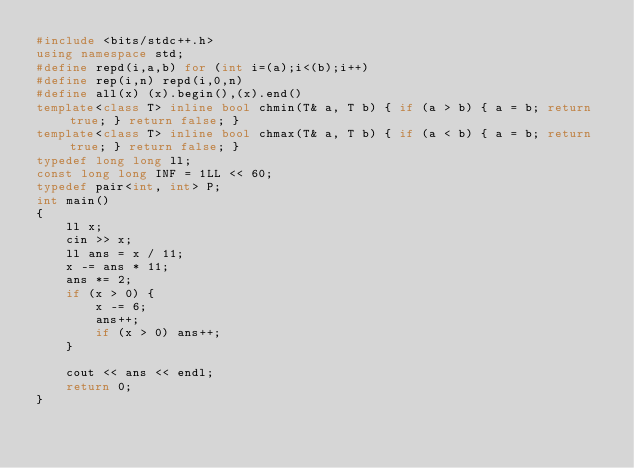<code> <loc_0><loc_0><loc_500><loc_500><_C++_>#include <bits/stdc++.h>
using namespace std;
#define repd(i,a,b) for (int i=(a);i<(b);i++)
#define rep(i,n) repd(i,0,n)
#define all(x) (x).begin(),(x).end()
template<class T> inline bool chmin(T& a, T b) { if (a > b) { a = b; return true; } return false; }
template<class T> inline bool chmax(T& a, T b) { if (a < b) { a = b; return true; } return false; }
typedef long long ll;
const long long INF = 1LL << 60;
typedef pair<int, int> P;
int main()
{
    ll x;
    cin >> x;
    ll ans = x / 11;
    x -= ans * 11;
    ans *= 2;
    if (x > 0) {
        x -= 6;
        ans++;
        if (x > 0) ans++;
    }

    cout << ans << endl;
    return 0;
}</code> 